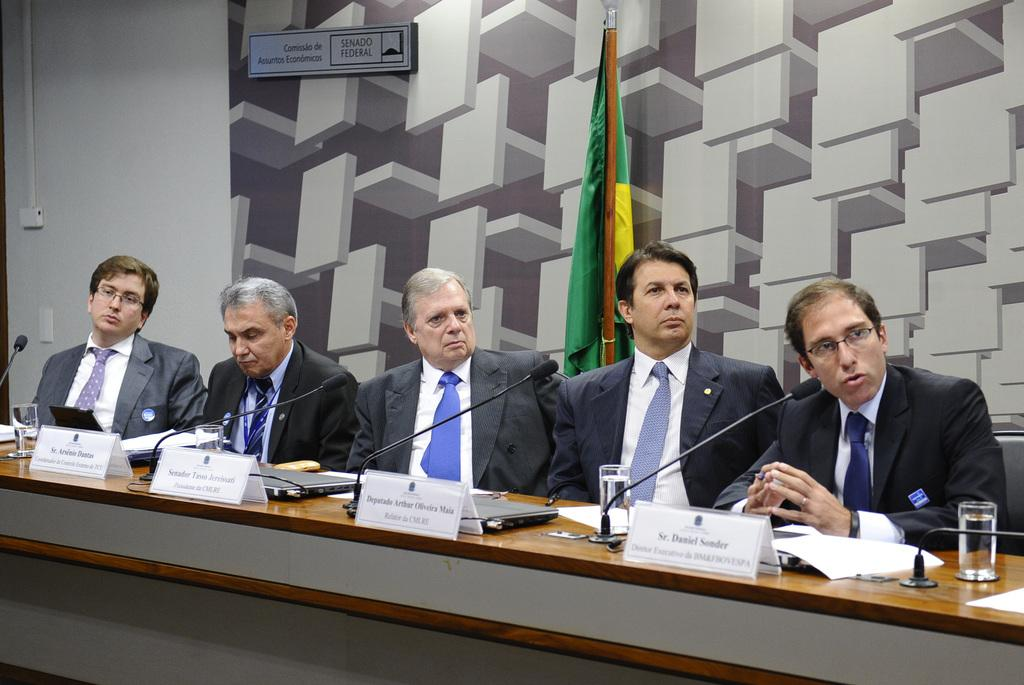How many men are sitting in the chairs in the image? There are 5 men sitting on chairs in the image. What are the men wearing that might provide warmth? 5 of the men are wearing coats. What is one man doing with a communication device? One man is talking into a microphone. What can be seen on the table in the image? There are water glasses on a table. Can you tell me how many goats are present in the image? There are no goats present in the image. What is the desire of the man holding the fork in the image? There is no man holding a fork in the image, as forks are not mentioned in the provided facts. 